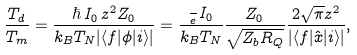Convert formula to latex. <formula><loc_0><loc_0><loc_500><loc_500>\frac { T _ { d } } { T _ { m } } = \frac { \hbar { \, } I _ { 0 } \, z ^ { 2 } Z _ { 0 } } { k _ { B } T _ { N } | \langle f | \phi | i \rangle | } = \frac { \frac { } { e } I _ { 0 } } { k _ { B } T _ { N } } \frac { Z _ { 0 } } { \sqrt { Z _ { b } R _ { Q } } } \frac { 2 \sqrt { \pi } z ^ { 2 } } { | \langle f | \hat { x } | i \rangle | } ,</formula> 